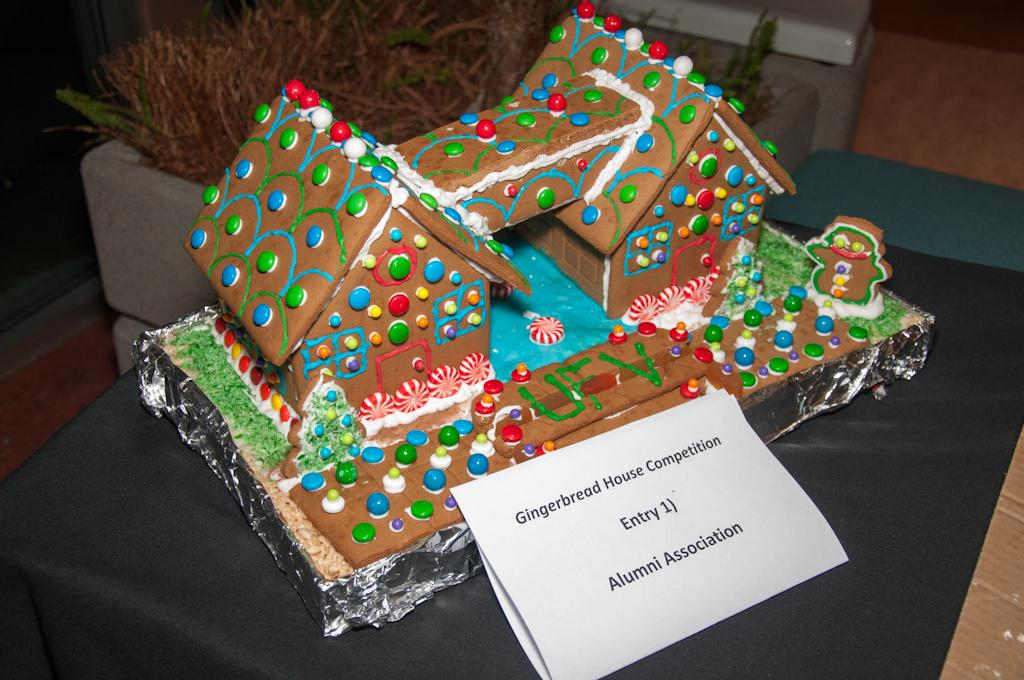What is the main subject in the center of the image? There is a gingerbread house in the center of the image. What else can be seen in the image besides the gingerbread house? There are plants at the top side of the image. Can you see a duck using a crayon to kick the gingerbread house in the image? No, there is no duck or crayon present in the image, and the gingerbread house is not being kicked. 